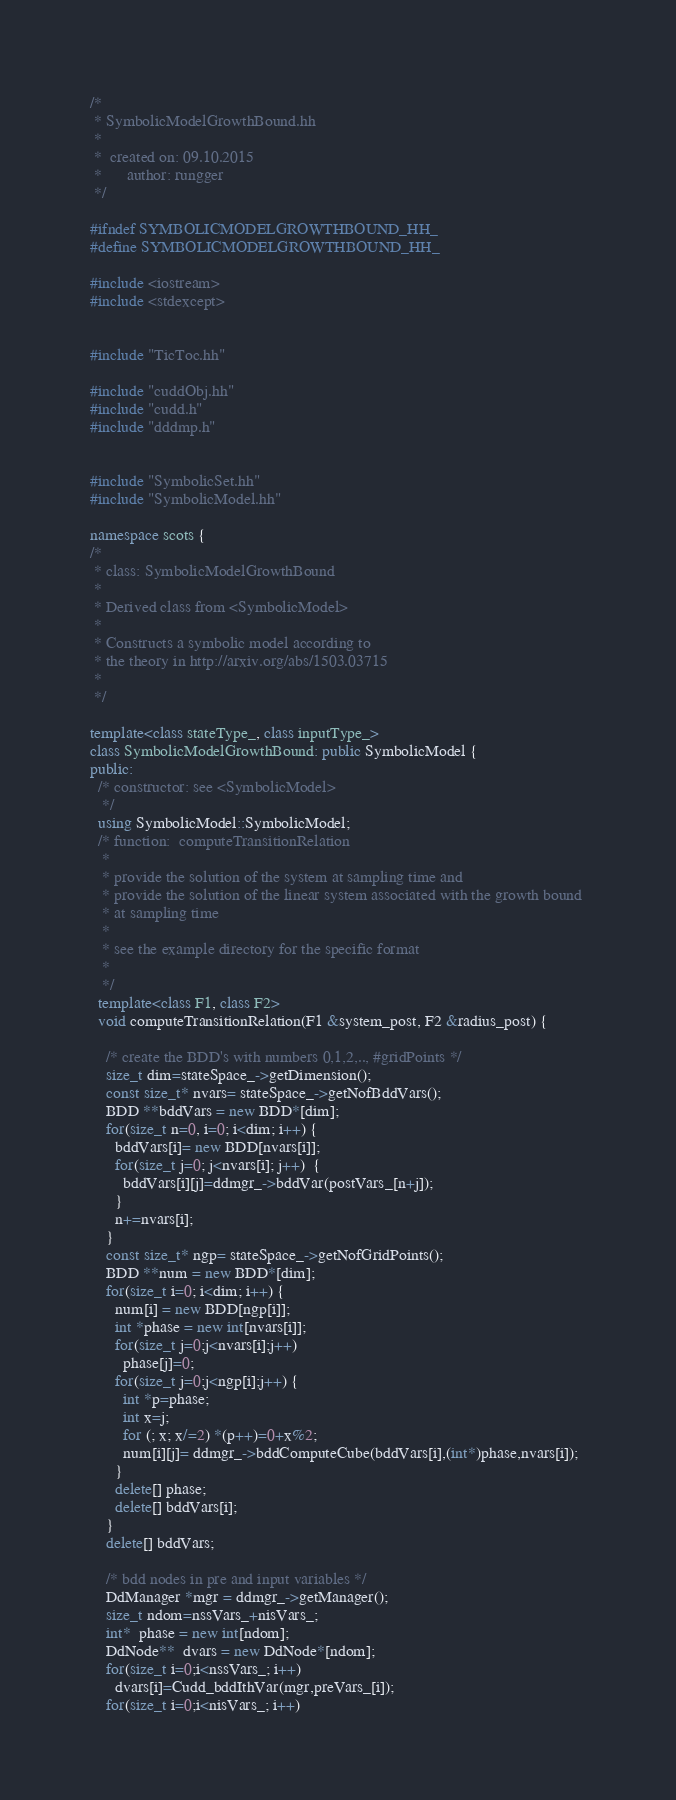Convert code to text. <code><loc_0><loc_0><loc_500><loc_500><_C++_>/*
 * SymbolicModelGrowthBound.hh
 *
 *  created on: 09.10.2015
 *      author: rungger
 */

#ifndef SYMBOLICMODELGROWTHBOUND_HH_
#define SYMBOLICMODELGROWTHBOUND_HH_

#include <iostream>
#include <stdexcept>


#include "TicToc.hh"

#include "cuddObj.hh"
#include "cudd.h"
#include "dddmp.h"


#include "SymbolicSet.hh"
#include "SymbolicModel.hh"

namespace scots {
/*
 * class: SymbolicModelGrowthBound
 *
 * Derived class from <SymbolicModel>
 * 
 * Constructs a symbolic model according to
 * the theory in http://arxiv.org/abs/1503.03715
 *
 */

template<class stateType_, class inputType_>
class SymbolicModelGrowthBound: public SymbolicModel {
public:
  /* constructor: see <SymbolicModel>
   */
  using SymbolicModel::SymbolicModel;
  /* function:  computeTransitionRelation
   *
   * provide the solution of the system at sampling time and
   * provide the solution of the linear system associated with the growth bound 
   * at sampling time 
   *
   * see the example directory for the specific format
   *
   */
  template<class F1, class F2>
  void computeTransitionRelation(F1 &system_post, F2 &radius_post) {

    /* create the BDD's with numbers 0,1,2,.., #gridPoints */
    size_t dim=stateSpace_->getDimension();
    const size_t* nvars= stateSpace_->getNofBddVars();
    BDD **bddVars = new BDD*[dim];
    for(size_t n=0, i=0; i<dim; i++) {
      bddVars[i]= new BDD[nvars[i]];
      for(size_t j=0; j<nvars[i]; j++)  {
        bddVars[i][j]=ddmgr_->bddVar(postVars_[n+j]);
      }
      n+=nvars[i];
    }
    const size_t* ngp= stateSpace_->getNofGridPoints();
    BDD **num = new BDD*[dim];
    for(size_t i=0; i<dim; i++) {
      num[i] = new BDD[ngp[i]];
      int *phase = new int[nvars[i]];
      for(size_t j=0;j<nvars[i];j++)
        phase[j]=0;
      for(size_t j=0;j<ngp[i];j++) {
        int *p=phase;
        int x=j;
        for (; x; x/=2) *(p++)=0+x%2;
        num[i][j]= ddmgr_->bddComputeCube(bddVars[i],(int*)phase,nvars[i]);
      }
      delete[] phase;
      delete[] bddVars[i];
    }
    delete[] bddVars;

    /* bdd nodes in pre and input variables */
    DdManager *mgr = ddmgr_->getManager();
    size_t ndom=nssVars_+nisVars_;
    int*  phase = new int[ndom];
    DdNode**  dvars = new DdNode*[ndom];
    for(size_t i=0;i<nssVars_; i++)
      dvars[i]=Cudd_bddIthVar(mgr,preVars_[i]);
    for(size_t i=0;i<nisVars_; i++)</code> 